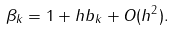<formula> <loc_0><loc_0><loc_500><loc_500>\beta _ { k } = 1 + h b _ { k } + O ( h ^ { 2 } ) .</formula> 